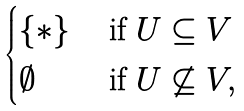Convert formula to latex. <formula><loc_0><loc_0><loc_500><loc_500>\begin{cases} \{ \ast \} & \ \text {if} \ U \subseteq V \\ \emptyset & \ \text {if} \ U \not \subseteq V , \end{cases}</formula> 